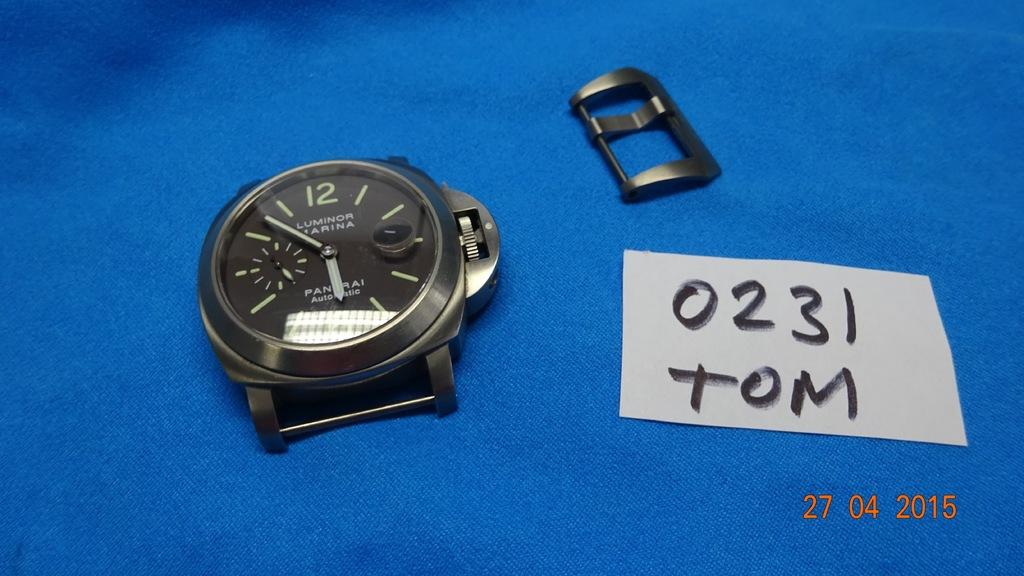<image>
Relay a brief, clear account of the picture shown. A Luminor Marina watch is lying on a blue background. 